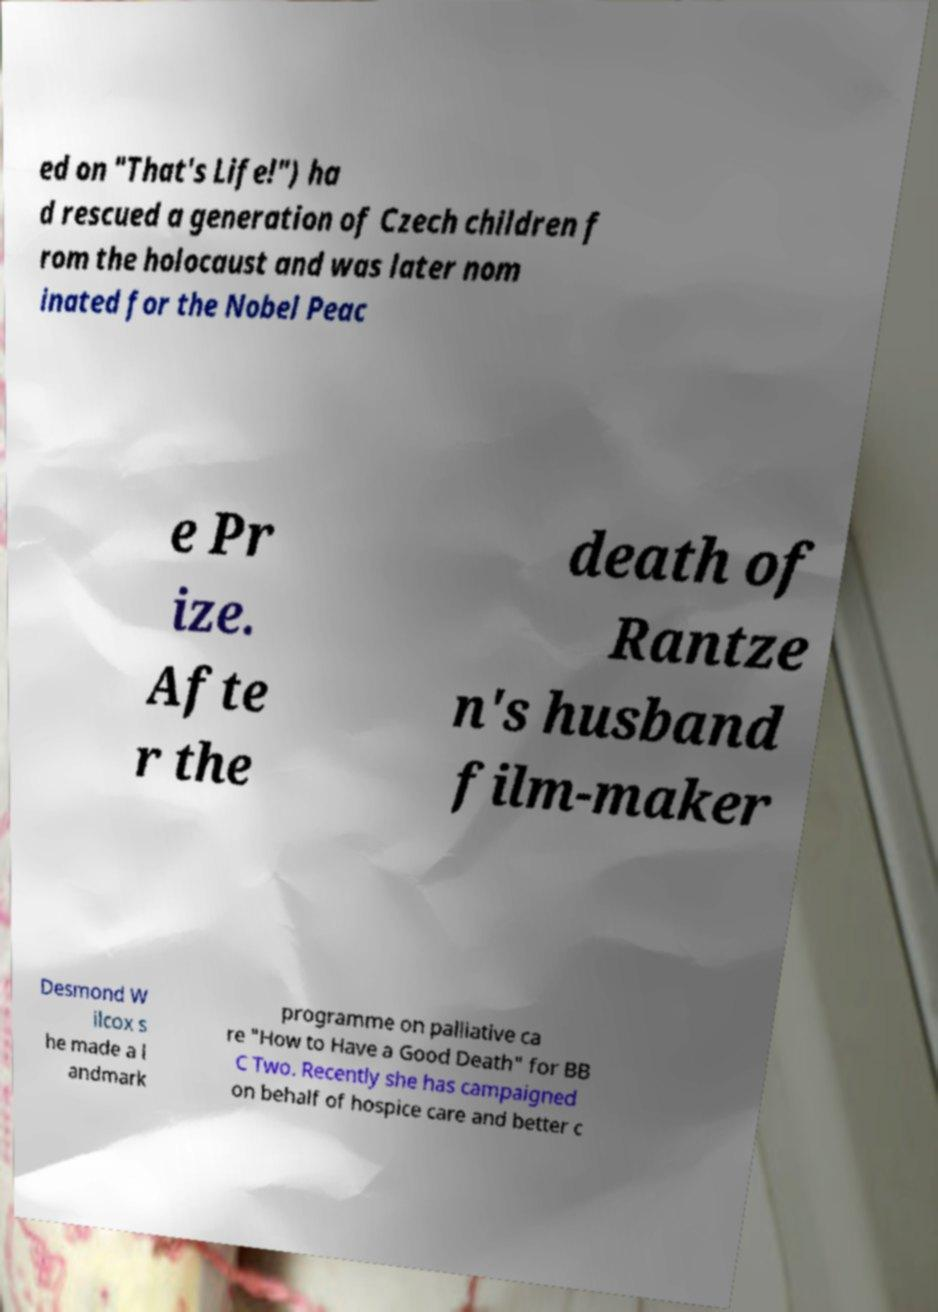For documentation purposes, I need the text within this image transcribed. Could you provide that? ed on "That's Life!") ha d rescued a generation of Czech children f rom the holocaust and was later nom inated for the Nobel Peac e Pr ize. Afte r the death of Rantze n's husband film-maker Desmond W ilcox s he made a l andmark programme on palliative ca re "How to Have a Good Death" for BB C Two. Recently she has campaigned on behalf of hospice care and better c 